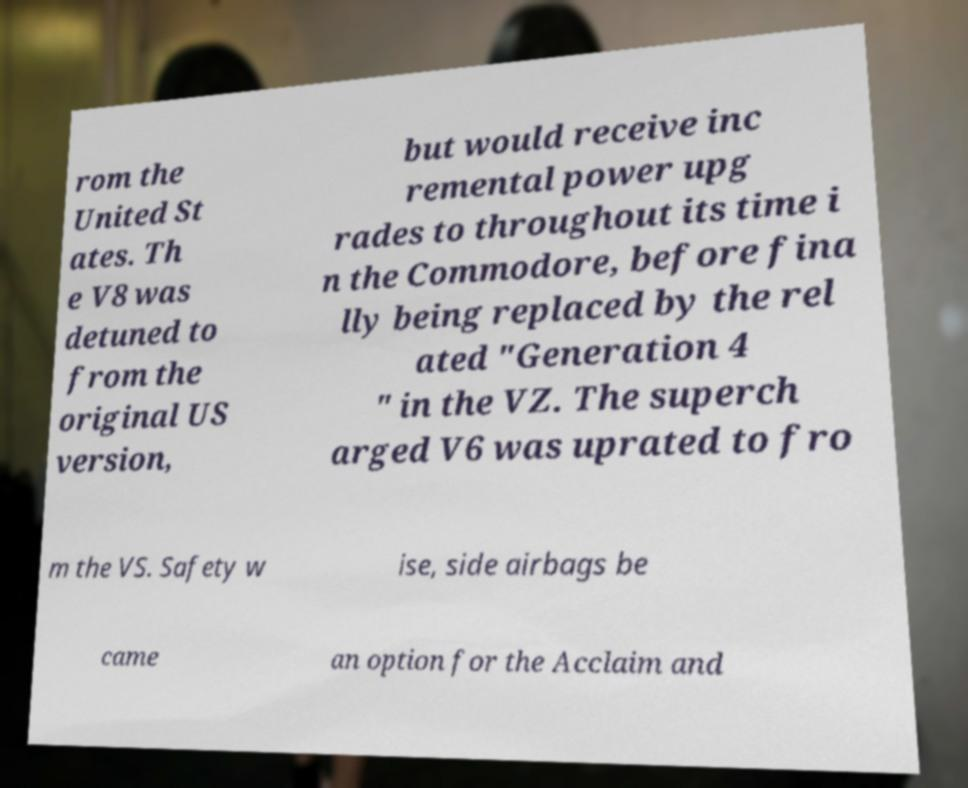Could you assist in decoding the text presented in this image and type it out clearly? rom the United St ates. Th e V8 was detuned to from the original US version, but would receive inc remental power upg rades to throughout its time i n the Commodore, before fina lly being replaced by the rel ated "Generation 4 " in the VZ. The superch arged V6 was uprated to fro m the VS. Safety w ise, side airbags be came an option for the Acclaim and 